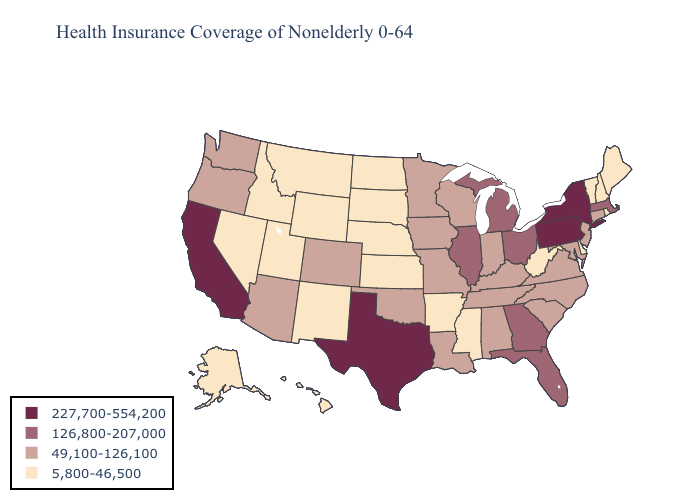Does the first symbol in the legend represent the smallest category?
Short answer required. No. What is the highest value in the USA?
Give a very brief answer. 227,700-554,200. Among the states that border Florida , does Georgia have the lowest value?
Keep it brief. No. What is the value of Wyoming?
Concise answer only. 5,800-46,500. Name the states that have a value in the range 49,100-126,100?
Write a very short answer. Alabama, Arizona, Colorado, Connecticut, Indiana, Iowa, Kentucky, Louisiana, Maryland, Minnesota, Missouri, New Jersey, North Carolina, Oklahoma, Oregon, South Carolina, Tennessee, Virginia, Washington, Wisconsin. What is the value of Arkansas?
Answer briefly. 5,800-46,500. What is the value of Oklahoma?
Write a very short answer. 49,100-126,100. What is the value of Maine?
Keep it brief. 5,800-46,500. What is the value of Pennsylvania?
Short answer required. 227,700-554,200. Is the legend a continuous bar?
Short answer required. No. Does New York have the same value as California?
Quick response, please. Yes. Name the states that have a value in the range 227,700-554,200?
Be succinct. California, New York, Pennsylvania, Texas. Does Utah have the lowest value in the USA?
Quick response, please. Yes. Name the states that have a value in the range 126,800-207,000?
Short answer required. Florida, Georgia, Illinois, Massachusetts, Michigan, Ohio. Name the states that have a value in the range 126,800-207,000?
Be succinct. Florida, Georgia, Illinois, Massachusetts, Michigan, Ohio. 